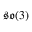Convert formula to latex. <formula><loc_0><loc_0><loc_500><loc_500>{ \mathfrak { s o } } ( 3 )</formula> 